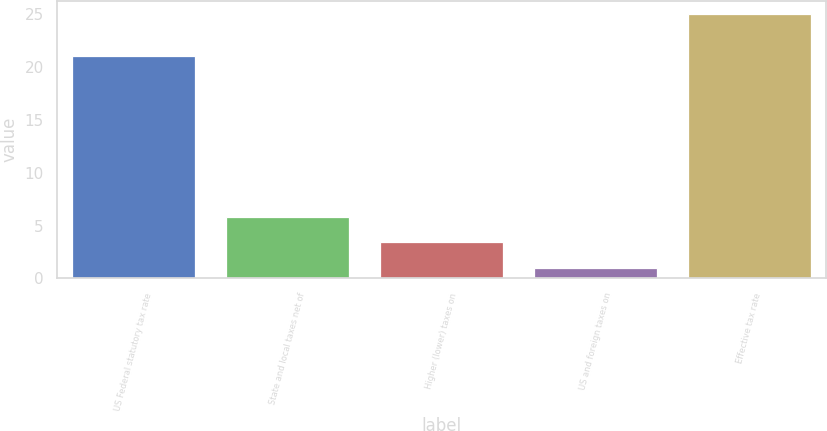<chart> <loc_0><loc_0><loc_500><loc_500><bar_chart><fcel>US Federal statutory tax rate<fcel>State and local taxes net of<fcel>Higher (lower) taxes on<fcel>US and foreign taxes on<fcel>Effective tax rate<nl><fcel>21<fcel>5.8<fcel>3.4<fcel>1<fcel>25<nl></chart> 